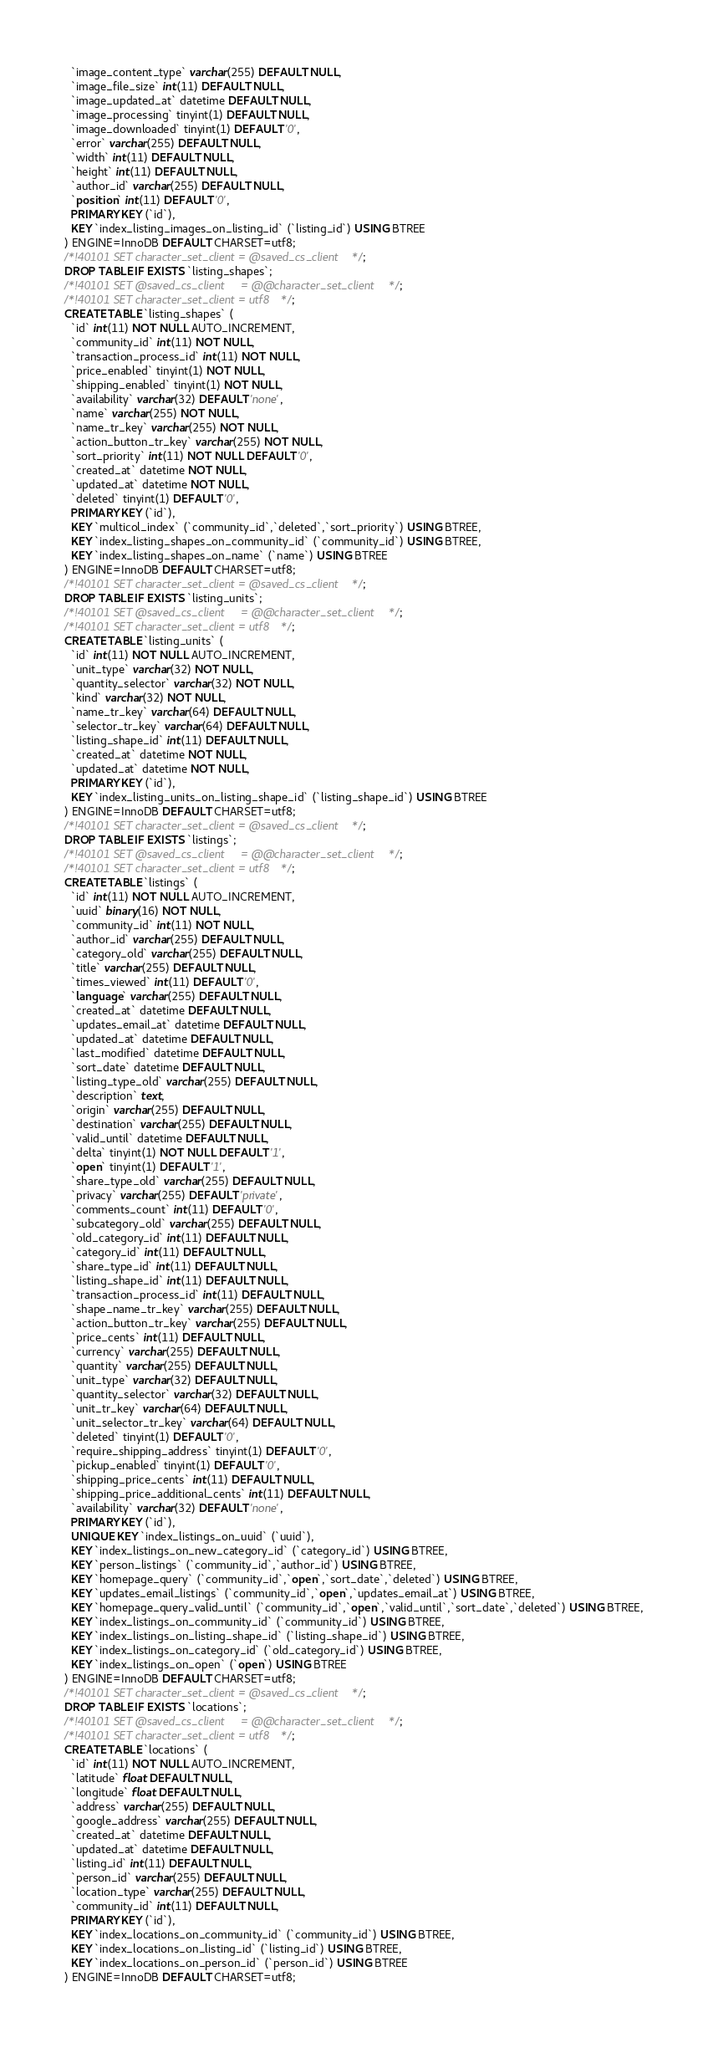Convert code to text. <code><loc_0><loc_0><loc_500><loc_500><_SQL_>  `image_content_type` varchar(255) DEFAULT NULL,
  `image_file_size` int(11) DEFAULT NULL,
  `image_updated_at` datetime DEFAULT NULL,
  `image_processing` tinyint(1) DEFAULT NULL,
  `image_downloaded` tinyint(1) DEFAULT '0',
  `error` varchar(255) DEFAULT NULL,
  `width` int(11) DEFAULT NULL,
  `height` int(11) DEFAULT NULL,
  `author_id` varchar(255) DEFAULT NULL,
  `position` int(11) DEFAULT '0',
  PRIMARY KEY (`id`),
  KEY `index_listing_images_on_listing_id` (`listing_id`) USING BTREE
) ENGINE=InnoDB DEFAULT CHARSET=utf8;
/*!40101 SET character_set_client = @saved_cs_client */;
DROP TABLE IF EXISTS `listing_shapes`;
/*!40101 SET @saved_cs_client     = @@character_set_client */;
/*!40101 SET character_set_client = utf8 */;
CREATE TABLE `listing_shapes` (
  `id` int(11) NOT NULL AUTO_INCREMENT,
  `community_id` int(11) NOT NULL,
  `transaction_process_id` int(11) NOT NULL,
  `price_enabled` tinyint(1) NOT NULL,
  `shipping_enabled` tinyint(1) NOT NULL,
  `availability` varchar(32) DEFAULT 'none',
  `name` varchar(255) NOT NULL,
  `name_tr_key` varchar(255) NOT NULL,
  `action_button_tr_key` varchar(255) NOT NULL,
  `sort_priority` int(11) NOT NULL DEFAULT '0',
  `created_at` datetime NOT NULL,
  `updated_at` datetime NOT NULL,
  `deleted` tinyint(1) DEFAULT '0',
  PRIMARY KEY (`id`),
  KEY `multicol_index` (`community_id`,`deleted`,`sort_priority`) USING BTREE,
  KEY `index_listing_shapes_on_community_id` (`community_id`) USING BTREE,
  KEY `index_listing_shapes_on_name` (`name`) USING BTREE
) ENGINE=InnoDB DEFAULT CHARSET=utf8;
/*!40101 SET character_set_client = @saved_cs_client */;
DROP TABLE IF EXISTS `listing_units`;
/*!40101 SET @saved_cs_client     = @@character_set_client */;
/*!40101 SET character_set_client = utf8 */;
CREATE TABLE `listing_units` (
  `id` int(11) NOT NULL AUTO_INCREMENT,
  `unit_type` varchar(32) NOT NULL,
  `quantity_selector` varchar(32) NOT NULL,
  `kind` varchar(32) NOT NULL,
  `name_tr_key` varchar(64) DEFAULT NULL,
  `selector_tr_key` varchar(64) DEFAULT NULL,
  `listing_shape_id` int(11) DEFAULT NULL,
  `created_at` datetime NOT NULL,
  `updated_at` datetime NOT NULL,
  PRIMARY KEY (`id`),
  KEY `index_listing_units_on_listing_shape_id` (`listing_shape_id`) USING BTREE
) ENGINE=InnoDB DEFAULT CHARSET=utf8;
/*!40101 SET character_set_client = @saved_cs_client */;
DROP TABLE IF EXISTS `listings`;
/*!40101 SET @saved_cs_client     = @@character_set_client */;
/*!40101 SET character_set_client = utf8 */;
CREATE TABLE `listings` (
  `id` int(11) NOT NULL AUTO_INCREMENT,
  `uuid` binary(16) NOT NULL,
  `community_id` int(11) NOT NULL,
  `author_id` varchar(255) DEFAULT NULL,
  `category_old` varchar(255) DEFAULT NULL,
  `title` varchar(255) DEFAULT NULL,
  `times_viewed` int(11) DEFAULT '0',
  `language` varchar(255) DEFAULT NULL,
  `created_at` datetime DEFAULT NULL,
  `updates_email_at` datetime DEFAULT NULL,
  `updated_at` datetime DEFAULT NULL,
  `last_modified` datetime DEFAULT NULL,
  `sort_date` datetime DEFAULT NULL,
  `listing_type_old` varchar(255) DEFAULT NULL,
  `description` text,
  `origin` varchar(255) DEFAULT NULL,
  `destination` varchar(255) DEFAULT NULL,
  `valid_until` datetime DEFAULT NULL,
  `delta` tinyint(1) NOT NULL DEFAULT '1',
  `open` tinyint(1) DEFAULT '1',
  `share_type_old` varchar(255) DEFAULT NULL,
  `privacy` varchar(255) DEFAULT 'private',
  `comments_count` int(11) DEFAULT '0',
  `subcategory_old` varchar(255) DEFAULT NULL,
  `old_category_id` int(11) DEFAULT NULL,
  `category_id` int(11) DEFAULT NULL,
  `share_type_id` int(11) DEFAULT NULL,
  `listing_shape_id` int(11) DEFAULT NULL,
  `transaction_process_id` int(11) DEFAULT NULL,
  `shape_name_tr_key` varchar(255) DEFAULT NULL,
  `action_button_tr_key` varchar(255) DEFAULT NULL,
  `price_cents` int(11) DEFAULT NULL,
  `currency` varchar(255) DEFAULT NULL,
  `quantity` varchar(255) DEFAULT NULL,
  `unit_type` varchar(32) DEFAULT NULL,
  `quantity_selector` varchar(32) DEFAULT NULL,
  `unit_tr_key` varchar(64) DEFAULT NULL,
  `unit_selector_tr_key` varchar(64) DEFAULT NULL,
  `deleted` tinyint(1) DEFAULT '0',
  `require_shipping_address` tinyint(1) DEFAULT '0',
  `pickup_enabled` tinyint(1) DEFAULT '0',
  `shipping_price_cents` int(11) DEFAULT NULL,
  `shipping_price_additional_cents` int(11) DEFAULT NULL,
  `availability` varchar(32) DEFAULT 'none',
  PRIMARY KEY (`id`),
  UNIQUE KEY `index_listings_on_uuid` (`uuid`),
  KEY `index_listings_on_new_category_id` (`category_id`) USING BTREE,
  KEY `person_listings` (`community_id`,`author_id`) USING BTREE,
  KEY `homepage_query` (`community_id`,`open`,`sort_date`,`deleted`) USING BTREE,
  KEY `updates_email_listings` (`community_id`,`open`,`updates_email_at`) USING BTREE,
  KEY `homepage_query_valid_until` (`community_id`,`open`,`valid_until`,`sort_date`,`deleted`) USING BTREE,
  KEY `index_listings_on_community_id` (`community_id`) USING BTREE,
  KEY `index_listings_on_listing_shape_id` (`listing_shape_id`) USING BTREE,
  KEY `index_listings_on_category_id` (`old_category_id`) USING BTREE,
  KEY `index_listings_on_open` (`open`) USING BTREE
) ENGINE=InnoDB DEFAULT CHARSET=utf8;
/*!40101 SET character_set_client = @saved_cs_client */;
DROP TABLE IF EXISTS `locations`;
/*!40101 SET @saved_cs_client     = @@character_set_client */;
/*!40101 SET character_set_client = utf8 */;
CREATE TABLE `locations` (
  `id` int(11) NOT NULL AUTO_INCREMENT,
  `latitude` float DEFAULT NULL,
  `longitude` float DEFAULT NULL,
  `address` varchar(255) DEFAULT NULL,
  `google_address` varchar(255) DEFAULT NULL,
  `created_at` datetime DEFAULT NULL,
  `updated_at` datetime DEFAULT NULL,
  `listing_id` int(11) DEFAULT NULL,
  `person_id` varchar(255) DEFAULT NULL,
  `location_type` varchar(255) DEFAULT NULL,
  `community_id` int(11) DEFAULT NULL,
  PRIMARY KEY (`id`),
  KEY `index_locations_on_community_id` (`community_id`) USING BTREE,
  KEY `index_locations_on_listing_id` (`listing_id`) USING BTREE,
  KEY `index_locations_on_person_id` (`person_id`) USING BTREE
) ENGINE=InnoDB DEFAULT CHARSET=utf8;</code> 